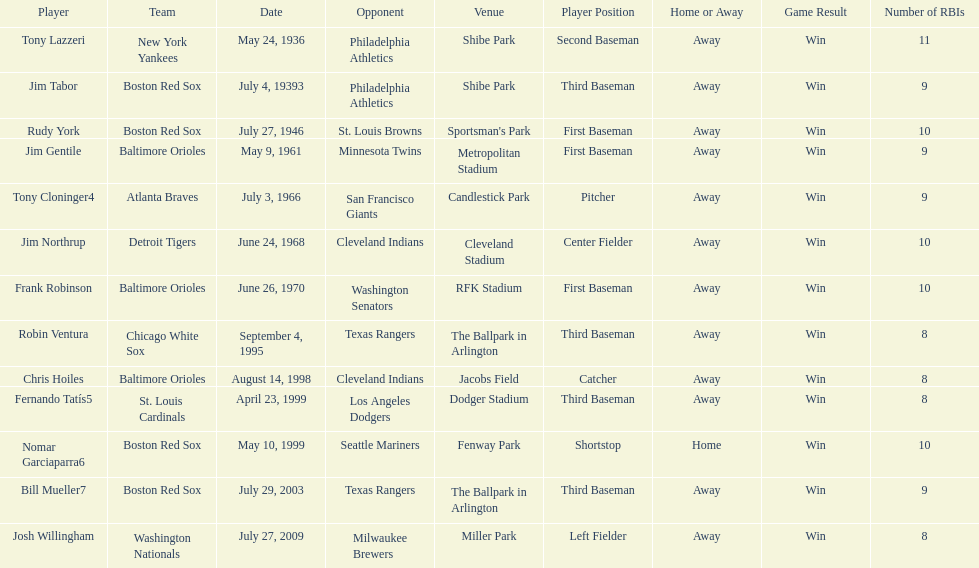Which teams faced off at miller park? Washington Nationals, Milwaukee Brewers. 